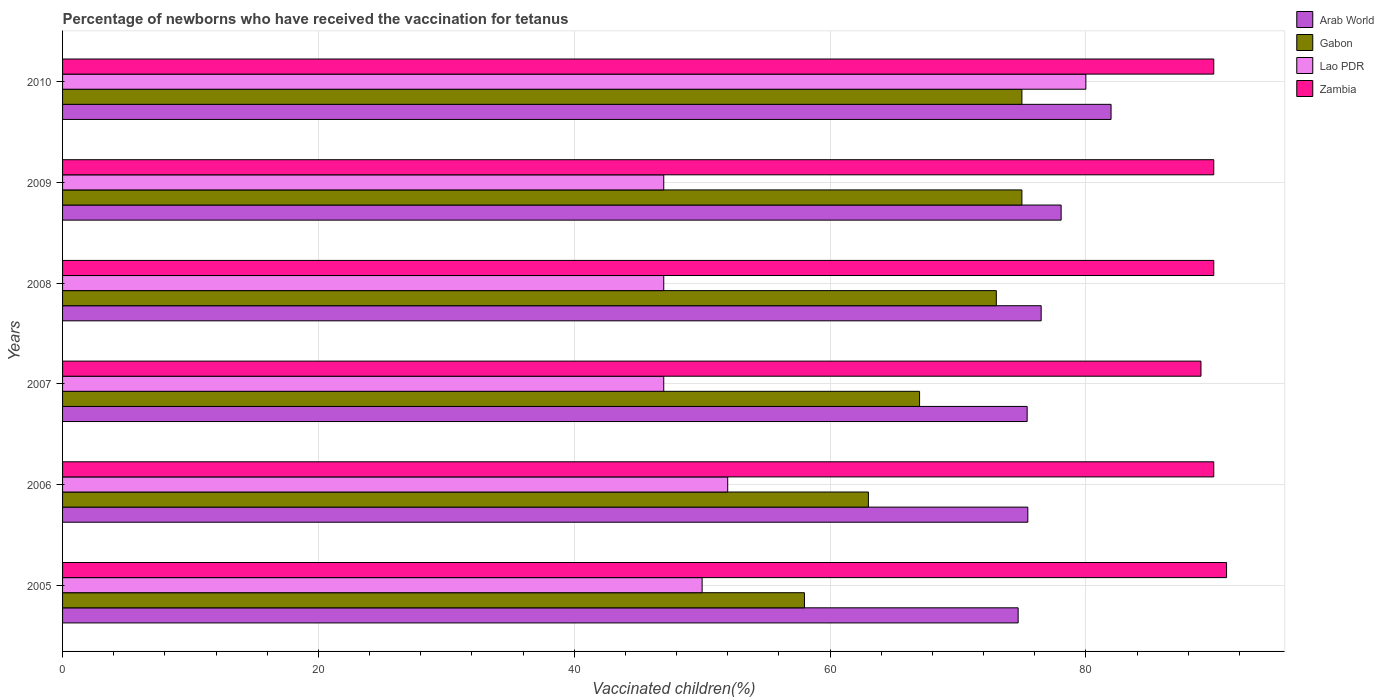How many different coloured bars are there?
Keep it short and to the point. 4. Are the number of bars per tick equal to the number of legend labels?
Your answer should be compact. Yes. Are the number of bars on each tick of the Y-axis equal?
Offer a terse response. Yes. How many bars are there on the 5th tick from the top?
Provide a short and direct response. 4. How many bars are there on the 2nd tick from the bottom?
Offer a terse response. 4. In how many cases, is the number of bars for a given year not equal to the number of legend labels?
Give a very brief answer. 0. Across all years, what is the maximum percentage of vaccinated children in Arab World?
Your response must be concise. 81.97. Across all years, what is the minimum percentage of vaccinated children in Zambia?
Your answer should be compact. 89. In which year was the percentage of vaccinated children in Gabon maximum?
Provide a short and direct response. 2009. What is the total percentage of vaccinated children in Gabon in the graph?
Offer a terse response. 411. What is the difference between the percentage of vaccinated children in Lao PDR in 2007 and that in 2009?
Make the answer very short. 0. What is the average percentage of vaccinated children in Lao PDR per year?
Give a very brief answer. 53.83. In the year 2010, what is the difference between the percentage of vaccinated children in Gabon and percentage of vaccinated children in Arab World?
Make the answer very short. -6.97. In how many years, is the percentage of vaccinated children in Zambia greater than 4 %?
Your answer should be compact. 6. What is the ratio of the percentage of vaccinated children in Zambia in 2006 to that in 2007?
Provide a short and direct response. 1.01. Is the difference between the percentage of vaccinated children in Gabon in 2009 and 2010 greater than the difference between the percentage of vaccinated children in Arab World in 2009 and 2010?
Keep it short and to the point. Yes. What is the difference between the highest and the second highest percentage of vaccinated children in Zambia?
Give a very brief answer. 1. What is the difference between the highest and the lowest percentage of vaccinated children in Gabon?
Provide a succinct answer. 17. In how many years, is the percentage of vaccinated children in Zambia greater than the average percentage of vaccinated children in Zambia taken over all years?
Give a very brief answer. 1. Is it the case that in every year, the sum of the percentage of vaccinated children in Gabon and percentage of vaccinated children in Arab World is greater than the sum of percentage of vaccinated children in Lao PDR and percentage of vaccinated children in Zambia?
Offer a very short reply. No. What does the 3rd bar from the top in 2008 represents?
Your answer should be compact. Gabon. What does the 3rd bar from the bottom in 2005 represents?
Give a very brief answer. Lao PDR. How many bars are there?
Give a very brief answer. 24. How many years are there in the graph?
Keep it short and to the point. 6. Are the values on the major ticks of X-axis written in scientific E-notation?
Give a very brief answer. No. Does the graph contain any zero values?
Provide a short and direct response. No. Does the graph contain grids?
Give a very brief answer. Yes. How are the legend labels stacked?
Ensure brevity in your answer.  Vertical. What is the title of the graph?
Ensure brevity in your answer.  Percentage of newborns who have received the vaccination for tetanus. Does "Faeroe Islands" appear as one of the legend labels in the graph?
Ensure brevity in your answer.  No. What is the label or title of the X-axis?
Make the answer very short. Vaccinated children(%). What is the label or title of the Y-axis?
Make the answer very short. Years. What is the Vaccinated children(%) of Arab World in 2005?
Ensure brevity in your answer.  74.71. What is the Vaccinated children(%) in Lao PDR in 2005?
Provide a succinct answer. 50. What is the Vaccinated children(%) of Zambia in 2005?
Give a very brief answer. 91. What is the Vaccinated children(%) in Arab World in 2006?
Ensure brevity in your answer.  75.46. What is the Vaccinated children(%) in Arab World in 2007?
Provide a short and direct response. 75.41. What is the Vaccinated children(%) of Gabon in 2007?
Provide a short and direct response. 67. What is the Vaccinated children(%) of Zambia in 2007?
Your response must be concise. 89. What is the Vaccinated children(%) in Arab World in 2008?
Keep it short and to the point. 76.51. What is the Vaccinated children(%) in Gabon in 2008?
Keep it short and to the point. 73. What is the Vaccinated children(%) of Lao PDR in 2008?
Offer a very short reply. 47. What is the Vaccinated children(%) of Zambia in 2008?
Provide a short and direct response. 90. What is the Vaccinated children(%) of Arab World in 2009?
Keep it short and to the point. 78.07. What is the Vaccinated children(%) of Gabon in 2009?
Keep it short and to the point. 75. What is the Vaccinated children(%) in Zambia in 2009?
Your response must be concise. 90. What is the Vaccinated children(%) of Arab World in 2010?
Your answer should be very brief. 81.97. What is the Vaccinated children(%) in Gabon in 2010?
Keep it short and to the point. 75. What is the Vaccinated children(%) of Lao PDR in 2010?
Give a very brief answer. 80. What is the Vaccinated children(%) in Zambia in 2010?
Your answer should be very brief. 90. Across all years, what is the maximum Vaccinated children(%) in Arab World?
Provide a short and direct response. 81.97. Across all years, what is the maximum Vaccinated children(%) of Gabon?
Give a very brief answer. 75. Across all years, what is the maximum Vaccinated children(%) of Zambia?
Your response must be concise. 91. Across all years, what is the minimum Vaccinated children(%) in Arab World?
Offer a very short reply. 74.71. Across all years, what is the minimum Vaccinated children(%) of Zambia?
Keep it short and to the point. 89. What is the total Vaccinated children(%) of Arab World in the graph?
Make the answer very short. 462.12. What is the total Vaccinated children(%) in Gabon in the graph?
Keep it short and to the point. 411. What is the total Vaccinated children(%) in Lao PDR in the graph?
Offer a very short reply. 323. What is the total Vaccinated children(%) of Zambia in the graph?
Offer a terse response. 540. What is the difference between the Vaccinated children(%) of Arab World in 2005 and that in 2006?
Your answer should be compact. -0.76. What is the difference between the Vaccinated children(%) of Gabon in 2005 and that in 2006?
Your response must be concise. -5. What is the difference between the Vaccinated children(%) in Arab World in 2005 and that in 2007?
Provide a short and direct response. -0.71. What is the difference between the Vaccinated children(%) in Gabon in 2005 and that in 2007?
Your response must be concise. -9. What is the difference between the Vaccinated children(%) of Lao PDR in 2005 and that in 2007?
Offer a terse response. 3. What is the difference between the Vaccinated children(%) in Arab World in 2005 and that in 2008?
Give a very brief answer. -1.8. What is the difference between the Vaccinated children(%) of Gabon in 2005 and that in 2008?
Offer a terse response. -15. What is the difference between the Vaccinated children(%) in Arab World in 2005 and that in 2009?
Give a very brief answer. -3.36. What is the difference between the Vaccinated children(%) of Gabon in 2005 and that in 2009?
Ensure brevity in your answer.  -17. What is the difference between the Vaccinated children(%) of Lao PDR in 2005 and that in 2009?
Keep it short and to the point. 3. What is the difference between the Vaccinated children(%) of Arab World in 2005 and that in 2010?
Your answer should be compact. -7.26. What is the difference between the Vaccinated children(%) of Gabon in 2005 and that in 2010?
Your response must be concise. -17. What is the difference between the Vaccinated children(%) of Arab World in 2006 and that in 2007?
Offer a very short reply. 0.05. What is the difference between the Vaccinated children(%) in Lao PDR in 2006 and that in 2007?
Your response must be concise. 5. What is the difference between the Vaccinated children(%) of Zambia in 2006 and that in 2007?
Your answer should be compact. 1. What is the difference between the Vaccinated children(%) in Arab World in 2006 and that in 2008?
Offer a very short reply. -1.04. What is the difference between the Vaccinated children(%) of Zambia in 2006 and that in 2008?
Provide a succinct answer. 0. What is the difference between the Vaccinated children(%) in Arab World in 2006 and that in 2009?
Provide a succinct answer. -2.6. What is the difference between the Vaccinated children(%) in Zambia in 2006 and that in 2009?
Keep it short and to the point. 0. What is the difference between the Vaccinated children(%) of Arab World in 2006 and that in 2010?
Keep it short and to the point. -6.51. What is the difference between the Vaccinated children(%) in Arab World in 2007 and that in 2008?
Your answer should be very brief. -1.09. What is the difference between the Vaccinated children(%) in Gabon in 2007 and that in 2008?
Make the answer very short. -6. What is the difference between the Vaccinated children(%) in Lao PDR in 2007 and that in 2008?
Your response must be concise. 0. What is the difference between the Vaccinated children(%) in Arab World in 2007 and that in 2009?
Make the answer very short. -2.66. What is the difference between the Vaccinated children(%) in Lao PDR in 2007 and that in 2009?
Your answer should be very brief. 0. What is the difference between the Vaccinated children(%) of Arab World in 2007 and that in 2010?
Provide a succinct answer. -6.56. What is the difference between the Vaccinated children(%) of Gabon in 2007 and that in 2010?
Your response must be concise. -8. What is the difference between the Vaccinated children(%) of Lao PDR in 2007 and that in 2010?
Ensure brevity in your answer.  -33. What is the difference between the Vaccinated children(%) in Arab World in 2008 and that in 2009?
Offer a very short reply. -1.56. What is the difference between the Vaccinated children(%) of Gabon in 2008 and that in 2009?
Offer a very short reply. -2. What is the difference between the Vaccinated children(%) of Arab World in 2008 and that in 2010?
Your response must be concise. -5.46. What is the difference between the Vaccinated children(%) of Gabon in 2008 and that in 2010?
Give a very brief answer. -2. What is the difference between the Vaccinated children(%) of Lao PDR in 2008 and that in 2010?
Your answer should be compact. -33. What is the difference between the Vaccinated children(%) of Arab World in 2009 and that in 2010?
Provide a short and direct response. -3.9. What is the difference between the Vaccinated children(%) of Gabon in 2009 and that in 2010?
Your answer should be very brief. 0. What is the difference between the Vaccinated children(%) of Lao PDR in 2009 and that in 2010?
Your answer should be compact. -33. What is the difference between the Vaccinated children(%) in Arab World in 2005 and the Vaccinated children(%) in Gabon in 2006?
Make the answer very short. 11.71. What is the difference between the Vaccinated children(%) in Arab World in 2005 and the Vaccinated children(%) in Lao PDR in 2006?
Keep it short and to the point. 22.71. What is the difference between the Vaccinated children(%) in Arab World in 2005 and the Vaccinated children(%) in Zambia in 2006?
Your response must be concise. -15.29. What is the difference between the Vaccinated children(%) in Gabon in 2005 and the Vaccinated children(%) in Zambia in 2006?
Ensure brevity in your answer.  -32. What is the difference between the Vaccinated children(%) in Arab World in 2005 and the Vaccinated children(%) in Gabon in 2007?
Ensure brevity in your answer.  7.71. What is the difference between the Vaccinated children(%) of Arab World in 2005 and the Vaccinated children(%) of Lao PDR in 2007?
Provide a succinct answer. 27.71. What is the difference between the Vaccinated children(%) of Arab World in 2005 and the Vaccinated children(%) of Zambia in 2007?
Give a very brief answer. -14.29. What is the difference between the Vaccinated children(%) in Gabon in 2005 and the Vaccinated children(%) in Lao PDR in 2007?
Your answer should be very brief. 11. What is the difference between the Vaccinated children(%) in Gabon in 2005 and the Vaccinated children(%) in Zambia in 2007?
Provide a succinct answer. -31. What is the difference between the Vaccinated children(%) in Lao PDR in 2005 and the Vaccinated children(%) in Zambia in 2007?
Your answer should be compact. -39. What is the difference between the Vaccinated children(%) of Arab World in 2005 and the Vaccinated children(%) of Gabon in 2008?
Offer a very short reply. 1.71. What is the difference between the Vaccinated children(%) of Arab World in 2005 and the Vaccinated children(%) of Lao PDR in 2008?
Ensure brevity in your answer.  27.71. What is the difference between the Vaccinated children(%) of Arab World in 2005 and the Vaccinated children(%) of Zambia in 2008?
Offer a terse response. -15.29. What is the difference between the Vaccinated children(%) in Gabon in 2005 and the Vaccinated children(%) in Lao PDR in 2008?
Your answer should be compact. 11. What is the difference between the Vaccinated children(%) in Gabon in 2005 and the Vaccinated children(%) in Zambia in 2008?
Keep it short and to the point. -32. What is the difference between the Vaccinated children(%) of Arab World in 2005 and the Vaccinated children(%) of Gabon in 2009?
Give a very brief answer. -0.29. What is the difference between the Vaccinated children(%) of Arab World in 2005 and the Vaccinated children(%) of Lao PDR in 2009?
Your answer should be compact. 27.71. What is the difference between the Vaccinated children(%) in Arab World in 2005 and the Vaccinated children(%) in Zambia in 2009?
Offer a very short reply. -15.29. What is the difference between the Vaccinated children(%) of Gabon in 2005 and the Vaccinated children(%) of Zambia in 2009?
Provide a succinct answer. -32. What is the difference between the Vaccinated children(%) in Lao PDR in 2005 and the Vaccinated children(%) in Zambia in 2009?
Your answer should be compact. -40. What is the difference between the Vaccinated children(%) in Arab World in 2005 and the Vaccinated children(%) in Gabon in 2010?
Provide a succinct answer. -0.29. What is the difference between the Vaccinated children(%) of Arab World in 2005 and the Vaccinated children(%) of Lao PDR in 2010?
Your answer should be compact. -5.29. What is the difference between the Vaccinated children(%) of Arab World in 2005 and the Vaccinated children(%) of Zambia in 2010?
Your response must be concise. -15.29. What is the difference between the Vaccinated children(%) in Gabon in 2005 and the Vaccinated children(%) in Zambia in 2010?
Your answer should be compact. -32. What is the difference between the Vaccinated children(%) in Lao PDR in 2005 and the Vaccinated children(%) in Zambia in 2010?
Your answer should be very brief. -40. What is the difference between the Vaccinated children(%) in Arab World in 2006 and the Vaccinated children(%) in Gabon in 2007?
Your answer should be compact. 8.46. What is the difference between the Vaccinated children(%) of Arab World in 2006 and the Vaccinated children(%) of Lao PDR in 2007?
Offer a terse response. 28.46. What is the difference between the Vaccinated children(%) of Arab World in 2006 and the Vaccinated children(%) of Zambia in 2007?
Your answer should be very brief. -13.54. What is the difference between the Vaccinated children(%) of Gabon in 2006 and the Vaccinated children(%) of Lao PDR in 2007?
Offer a terse response. 16. What is the difference between the Vaccinated children(%) of Lao PDR in 2006 and the Vaccinated children(%) of Zambia in 2007?
Ensure brevity in your answer.  -37. What is the difference between the Vaccinated children(%) of Arab World in 2006 and the Vaccinated children(%) of Gabon in 2008?
Your answer should be compact. 2.46. What is the difference between the Vaccinated children(%) of Arab World in 2006 and the Vaccinated children(%) of Lao PDR in 2008?
Your answer should be compact. 28.46. What is the difference between the Vaccinated children(%) of Arab World in 2006 and the Vaccinated children(%) of Zambia in 2008?
Your response must be concise. -14.54. What is the difference between the Vaccinated children(%) in Gabon in 2006 and the Vaccinated children(%) in Lao PDR in 2008?
Keep it short and to the point. 16. What is the difference between the Vaccinated children(%) of Lao PDR in 2006 and the Vaccinated children(%) of Zambia in 2008?
Ensure brevity in your answer.  -38. What is the difference between the Vaccinated children(%) in Arab World in 2006 and the Vaccinated children(%) in Gabon in 2009?
Provide a short and direct response. 0.46. What is the difference between the Vaccinated children(%) of Arab World in 2006 and the Vaccinated children(%) of Lao PDR in 2009?
Provide a succinct answer. 28.46. What is the difference between the Vaccinated children(%) of Arab World in 2006 and the Vaccinated children(%) of Zambia in 2009?
Provide a short and direct response. -14.54. What is the difference between the Vaccinated children(%) in Gabon in 2006 and the Vaccinated children(%) in Lao PDR in 2009?
Your answer should be very brief. 16. What is the difference between the Vaccinated children(%) of Gabon in 2006 and the Vaccinated children(%) of Zambia in 2009?
Offer a very short reply. -27. What is the difference between the Vaccinated children(%) in Lao PDR in 2006 and the Vaccinated children(%) in Zambia in 2009?
Give a very brief answer. -38. What is the difference between the Vaccinated children(%) of Arab World in 2006 and the Vaccinated children(%) of Gabon in 2010?
Keep it short and to the point. 0.46. What is the difference between the Vaccinated children(%) of Arab World in 2006 and the Vaccinated children(%) of Lao PDR in 2010?
Your answer should be compact. -4.54. What is the difference between the Vaccinated children(%) of Arab World in 2006 and the Vaccinated children(%) of Zambia in 2010?
Your response must be concise. -14.54. What is the difference between the Vaccinated children(%) in Lao PDR in 2006 and the Vaccinated children(%) in Zambia in 2010?
Offer a terse response. -38. What is the difference between the Vaccinated children(%) in Arab World in 2007 and the Vaccinated children(%) in Gabon in 2008?
Make the answer very short. 2.41. What is the difference between the Vaccinated children(%) in Arab World in 2007 and the Vaccinated children(%) in Lao PDR in 2008?
Offer a terse response. 28.41. What is the difference between the Vaccinated children(%) in Arab World in 2007 and the Vaccinated children(%) in Zambia in 2008?
Provide a short and direct response. -14.59. What is the difference between the Vaccinated children(%) in Gabon in 2007 and the Vaccinated children(%) in Zambia in 2008?
Give a very brief answer. -23. What is the difference between the Vaccinated children(%) in Lao PDR in 2007 and the Vaccinated children(%) in Zambia in 2008?
Provide a succinct answer. -43. What is the difference between the Vaccinated children(%) in Arab World in 2007 and the Vaccinated children(%) in Gabon in 2009?
Your response must be concise. 0.41. What is the difference between the Vaccinated children(%) in Arab World in 2007 and the Vaccinated children(%) in Lao PDR in 2009?
Offer a very short reply. 28.41. What is the difference between the Vaccinated children(%) in Arab World in 2007 and the Vaccinated children(%) in Zambia in 2009?
Make the answer very short. -14.59. What is the difference between the Vaccinated children(%) in Gabon in 2007 and the Vaccinated children(%) in Lao PDR in 2009?
Make the answer very short. 20. What is the difference between the Vaccinated children(%) in Gabon in 2007 and the Vaccinated children(%) in Zambia in 2009?
Keep it short and to the point. -23. What is the difference between the Vaccinated children(%) of Lao PDR in 2007 and the Vaccinated children(%) of Zambia in 2009?
Ensure brevity in your answer.  -43. What is the difference between the Vaccinated children(%) in Arab World in 2007 and the Vaccinated children(%) in Gabon in 2010?
Your response must be concise. 0.41. What is the difference between the Vaccinated children(%) of Arab World in 2007 and the Vaccinated children(%) of Lao PDR in 2010?
Offer a very short reply. -4.59. What is the difference between the Vaccinated children(%) of Arab World in 2007 and the Vaccinated children(%) of Zambia in 2010?
Provide a succinct answer. -14.59. What is the difference between the Vaccinated children(%) of Gabon in 2007 and the Vaccinated children(%) of Zambia in 2010?
Give a very brief answer. -23. What is the difference between the Vaccinated children(%) in Lao PDR in 2007 and the Vaccinated children(%) in Zambia in 2010?
Offer a very short reply. -43. What is the difference between the Vaccinated children(%) of Arab World in 2008 and the Vaccinated children(%) of Gabon in 2009?
Your response must be concise. 1.51. What is the difference between the Vaccinated children(%) of Arab World in 2008 and the Vaccinated children(%) of Lao PDR in 2009?
Give a very brief answer. 29.51. What is the difference between the Vaccinated children(%) in Arab World in 2008 and the Vaccinated children(%) in Zambia in 2009?
Give a very brief answer. -13.49. What is the difference between the Vaccinated children(%) in Gabon in 2008 and the Vaccinated children(%) in Zambia in 2009?
Keep it short and to the point. -17. What is the difference between the Vaccinated children(%) in Lao PDR in 2008 and the Vaccinated children(%) in Zambia in 2009?
Offer a terse response. -43. What is the difference between the Vaccinated children(%) of Arab World in 2008 and the Vaccinated children(%) of Gabon in 2010?
Keep it short and to the point. 1.51. What is the difference between the Vaccinated children(%) of Arab World in 2008 and the Vaccinated children(%) of Lao PDR in 2010?
Offer a terse response. -3.49. What is the difference between the Vaccinated children(%) of Arab World in 2008 and the Vaccinated children(%) of Zambia in 2010?
Ensure brevity in your answer.  -13.49. What is the difference between the Vaccinated children(%) in Gabon in 2008 and the Vaccinated children(%) in Zambia in 2010?
Make the answer very short. -17. What is the difference between the Vaccinated children(%) in Lao PDR in 2008 and the Vaccinated children(%) in Zambia in 2010?
Offer a very short reply. -43. What is the difference between the Vaccinated children(%) of Arab World in 2009 and the Vaccinated children(%) of Gabon in 2010?
Keep it short and to the point. 3.07. What is the difference between the Vaccinated children(%) in Arab World in 2009 and the Vaccinated children(%) in Lao PDR in 2010?
Provide a short and direct response. -1.93. What is the difference between the Vaccinated children(%) in Arab World in 2009 and the Vaccinated children(%) in Zambia in 2010?
Keep it short and to the point. -11.93. What is the difference between the Vaccinated children(%) in Lao PDR in 2009 and the Vaccinated children(%) in Zambia in 2010?
Keep it short and to the point. -43. What is the average Vaccinated children(%) in Arab World per year?
Give a very brief answer. 77.02. What is the average Vaccinated children(%) of Gabon per year?
Make the answer very short. 68.5. What is the average Vaccinated children(%) in Lao PDR per year?
Your answer should be compact. 53.83. In the year 2005, what is the difference between the Vaccinated children(%) in Arab World and Vaccinated children(%) in Gabon?
Your answer should be compact. 16.71. In the year 2005, what is the difference between the Vaccinated children(%) of Arab World and Vaccinated children(%) of Lao PDR?
Your answer should be compact. 24.71. In the year 2005, what is the difference between the Vaccinated children(%) of Arab World and Vaccinated children(%) of Zambia?
Offer a terse response. -16.29. In the year 2005, what is the difference between the Vaccinated children(%) in Gabon and Vaccinated children(%) in Lao PDR?
Give a very brief answer. 8. In the year 2005, what is the difference between the Vaccinated children(%) in Gabon and Vaccinated children(%) in Zambia?
Give a very brief answer. -33. In the year 2005, what is the difference between the Vaccinated children(%) in Lao PDR and Vaccinated children(%) in Zambia?
Ensure brevity in your answer.  -41. In the year 2006, what is the difference between the Vaccinated children(%) of Arab World and Vaccinated children(%) of Gabon?
Make the answer very short. 12.46. In the year 2006, what is the difference between the Vaccinated children(%) in Arab World and Vaccinated children(%) in Lao PDR?
Keep it short and to the point. 23.46. In the year 2006, what is the difference between the Vaccinated children(%) of Arab World and Vaccinated children(%) of Zambia?
Offer a terse response. -14.54. In the year 2006, what is the difference between the Vaccinated children(%) in Gabon and Vaccinated children(%) in Lao PDR?
Give a very brief answer. 11. In the year 2006, what is the difference between the Vaccinated children(%) of Gabon and Vaccinated children(%) of Zambia?
Your answer should be very brief. -27. In the year 2006, what is the difference between the Vaccinated children(%) in Lao PDR and Vaccinated children(%) in Zambia?
Offer a terse response. -38. In the year 2007, what is the difference between the Vaccinated children(%) of Arab World and Vaccinated children(%) of Gabon?
Provide a short and direct response. 8.41. In the year 2007, what is the difference between the Vaccinated children(%) of Arab World and Vaccinated children(%) of Lao PDR?
Give a very brief answer. 28.41. In the year 2007, what is the difference between the Vaccinated children(%) in Arab World and Vaccinated children(%) in Zambia?
Make the answer very short. -13.59. In the year 2007, what is the difference between the Vaccinated children(%) in Gabon and Vaccinated children(%) in Lao PDR?
Offer a terse response. 20. In the year 2007, what is the difference between the Vaccinated children(%) of Gabon and Vaccinated children(%) of Zambia?
Offer a very short reply. -22. In the year 2007, what is the difference between the Vaccinated children(%) in Lao PDR and Vaccinated children(%) in Zambia?
Your answer should be compact. -42. In the year 2008, what is the difference between the Vaccinated children(%) in Arab World and Vaccinated children(%) in Gabon?
Provide a short and direct response. 3.51. In the year 2008, what is the difference between the Vaccinated children(%) of Arab World and Vaccinated children(%) of Lao PDR?
Your answer should be very brief. 29.51. In the year 2008, what is the difference between the Vaccinated children(%) of Arab World and Vaccinated children(%) of Zambia?
Offer a terse response. -13.49. In the year 2008, what is the difference between the Vaccinated children(%) of Lao PDR and Vaccinated children(%) of Zambia?
Offer a very short reply. -43. In the year 2009, what is the difference between the Vaccinated children(%) in Arab World and Vaccinated children(%) in Gabon?
Your response must be concise. 3.07. In the year 2009, what is the difference between the Vaccinated children(%) of Arab World and Vaccinated children(%) of Lao PDR?
Ensure brevity in your answer.  31.07. In the year 2009, what is the difference between the Vaccinated children(%) of Arab World and Vaccinated children(%) of Zambia?
Provide a succinct answer. -11.93. In the year 2009, what is the difference between the Vaccinated children(%) of Gabon and Vaccinated children(%) of Lao PDR?
Your answer should be compact. 28. In the year 2009, what is the difference between the Vaccinated children(%) of Gabon and Vaccinated children(%) of Zambia?
Your response must be concise. -15. In the year 2009, what is the difference between the Vaccinated children(%) in Lao PDR and Vaccinated children(%) in Zambia?
Your response must be concise. -43. In the year 2010, what is the difference between the Vaccinated children(%) in Arab World and Vaccinated children(%) in Gabon?
Provide a succinct answer. 6.97. In the year 2010, what is the difference between the Vaccinated children(%) in Arab World and Vaccinated children(%) in Lao PDR?
Offer a terse response. 1.97. In the year 2010, what is the difference between the Vaccinated children(%) in Arab World and Vaccinated children(%) in Zambia?
Ensure brevity in your answer.  -8.03. In the year 2010, what is the difference between the Vaccinated children(%) in Gabon and Vaccinated children(%) in Zambia?
Make the answer very short. -15. What is the ratio of the Vaccinated children(%) in Gabon in 2005 to that in 2006?
Offer a terse response. 0.92. What is the ratio of the Vaccinated children(%) in Lao PDR in 2005 to that in 2006?
Give a very brief answer. 0.96. What is the ratio of the Vaccinated children(%) of Zambia in 2005 to that in 2006?
Your response must be concise. 1.01. What is the ratio of the Vaccinated children(%) of Arab World in 2005 to that in 2007?
Provide a succinct answer. 0.99. What is the ratio of the Vaccinated children(%) in Gabon in 2005 to that in 2007?
Keep it short and to the point. 0.87. What is the ratio of the Vaccinated children(%) in Lao PDR in 2005 to that in 2007?
Offer a very short reply. 1.06. What is the ratio of the Vaccinated children(%) of Zambia in 2005 to that in 2007?
Offer a terse response. 1.02. What is the ratio of the Vaccinated children(%) of Arab World in 2005 to that in 2008?
Your answer should be very brief. 0.98. What is the ratio of the Vaccinated children(%) of Gabon in 2005 to that in 2008?
Make the answer very short. 0.79. What is the ratio of the Vaccinated children(%) of Lao PDR in 2005 to that in 2008?
Your answer should be compact. 1.06. What is the ratio of the Vaccinated children(%) in Zambia in 2005 to that in 2008?
Your response must be concise. 1.01. What is the ratio of the Vaccinated children(%) of Arab World in 2005 to that in 2009?
Keep it short and to the point. 0.96. What is the ratio of the Vaccinated children(%) of Gabon in 2005 to that in 2009?
Make the answer very short. 0.77. What is the ratio of the Vaccinated children(%) in Lao PDR in 2005 to that in 2009?
Ensure brevity in your answer.  1.06. What is the ratio of the Vaccinated children(%) in Zambia in 2005 to that in 2009?
Your answer should be compact. 1.01. What is the ratio of the Vaccinated children(%) in Arab World in 2005 to that in 2010?
Your response must be concise. 0.91. What is the ratio of the Vaccinated children(%) in Gabon in 2005 to that in 2010?
Keep it short and to the point. 0.77. What is the ratio of the Vaccinated children(%) in Zambia in 2005 to that in 2010?
Your response must be concise. 1.01. What is the ratio of the Vaccinated children(%) of Gabon in 2006 to that in 2007?
Give a very brief answer. 0.94. What is the ratio of the Vaccinated children(%) in Lao PDR in 2006 to that in 2007?
Give a very brief answer. 1.11. What is the ratio of the Vaccinated children(%) of Zambia in 2006 to that in 2007?
Your response must be concise. 1.01. What is the ratio of the Vaccinated children(%) of Arab World in 2006 to that in 2008?
Make the answer very short. 0.99. What is the ratio of the Vaccinated children(%) in Gabon in 2006 to that in 2008?
Provide a succinct answer. 0.86. What is the ratio of the Vaccinated children(%) in Lao PDR in 2006 to that in 2008?
Offer a terse response. 1.11. What is the ratio of the Vaccinated children(%) of Arab World in 2006 to that in 2009?
Ensure brevity in your answer.  0.97. What is the ratio of the Vaccinated children(%) of Gabon in 2006 to that in 2009?
Offer a very short reply. 0.84. What is the ratio of the Vaccinated children(%) of Lao PDR in 2006 to that in 2009?
Provide a succinct answer. 1.11. What is the ratio of the Vaccinated children(%) in Arab World in 2006 to that in 2010?
Provide a succinct answer. 0.92. What is the ratio of the Vaccinated children(%) of Gabon in 2006 to that in 2010?
Provide a short and direct response. 0.84. What is the ratio of the Vaccinated children(%) in Lao PDR in 2006 to that in 2010?
Offer a very short reply. 0.65. What is the ratio of the Vaccinated children(%) of Zambia in 2006 to that in 2010?
Keep it short and to the point. 1. What is the ratio of the Vaccinated children(%) in Arab World in 2007 to that in 2008?
Give a very brief answer. 0.99. What is the ratio of the Vaccinated children(%) of Gabon in 2007 to that in 2008?
Provide a succinct answer. 0.92. What is the ratio of the Vaccinated children(%) in Lao PDR in 2007 to that in 2008?
Provide a succinct answer. 1. What is the ratio of the Vaccinated children(%) in Zambia in 2007 to that in 2008?
Ensure brevity in your answer.  0.99. What is the ratio of the Vaccinated children(%) of Gabon in 2007 to that in 2009?
Ensure brevity in your answer.  0.89. What is the ratio of the Vaccinated children(%) of Lao PDR in 2007 to that in 2009?
Provide a succinct answer. 1. What is the ratio of the Vaccinated children(%) of Zambia in 2007 to that in 2009?
Keep it short and to the point. 0.99. What is the ratio of the Vaccinated children(%) in Arab World in 2007 to that in 2010?
Offer a very short reply. 0.92. What is the ratio of the Vaccinated children(%) of Gabon in 2007 to that in 2010?
Offer a terse response. 0.89. What is the ratio of the Vaccinated children(%) of Lao PDR in 2007 to that in 2010?
Your answer should be compact. 0.59. What is the ratio of the Vaccinated children(%) of Zambia in 2007 to that in 2010?
Ensure brevity in your answer.  0.99. What is the ratio of the Vaccinated children(%) in Gabon in 2008 to that in 2009?
Your answer should be very brief. 0.97. What is the ratio of the Vaccinated children(%) of Gabon in 2008 to that in 2010?
Your answer should be very brief. 0.97. What is the ratio of the Vaccinated children(%) in Lao PDR in 2008 to that in 2010?
Make the answer very short. 0.59. What is the ratio of the Vaccinated children(%) of Zambia in 2008 to that in 2010?
Ensure brevity in your answer.  1. What is the ratio of the Vaccinated children(%) in Arab World in 2009 to that in 2010?
Your answer should be very brief. 0.95. What is the ratio of the Vaccinated children(%) of Lao PDR in 2009 to that in 2010?
Offer a very short reply. 0.59. What is the difference between the highest and the second highest Vaccinated children(%) in Arab World?
Your answer should be compact. 3.9. What is the difference between the highest and the second highest Vaccinated children(%) in Lao PDR?
Your answer should be very brief. 28. What is the difference between the highest and the second highest Vaccinated children(%) of Zambia?
Offer a very short reply. 1. What is the difference between the highest and the lowest Vaccinated children(%) of Arab World?
Provide a short and direct response. 7.26. 